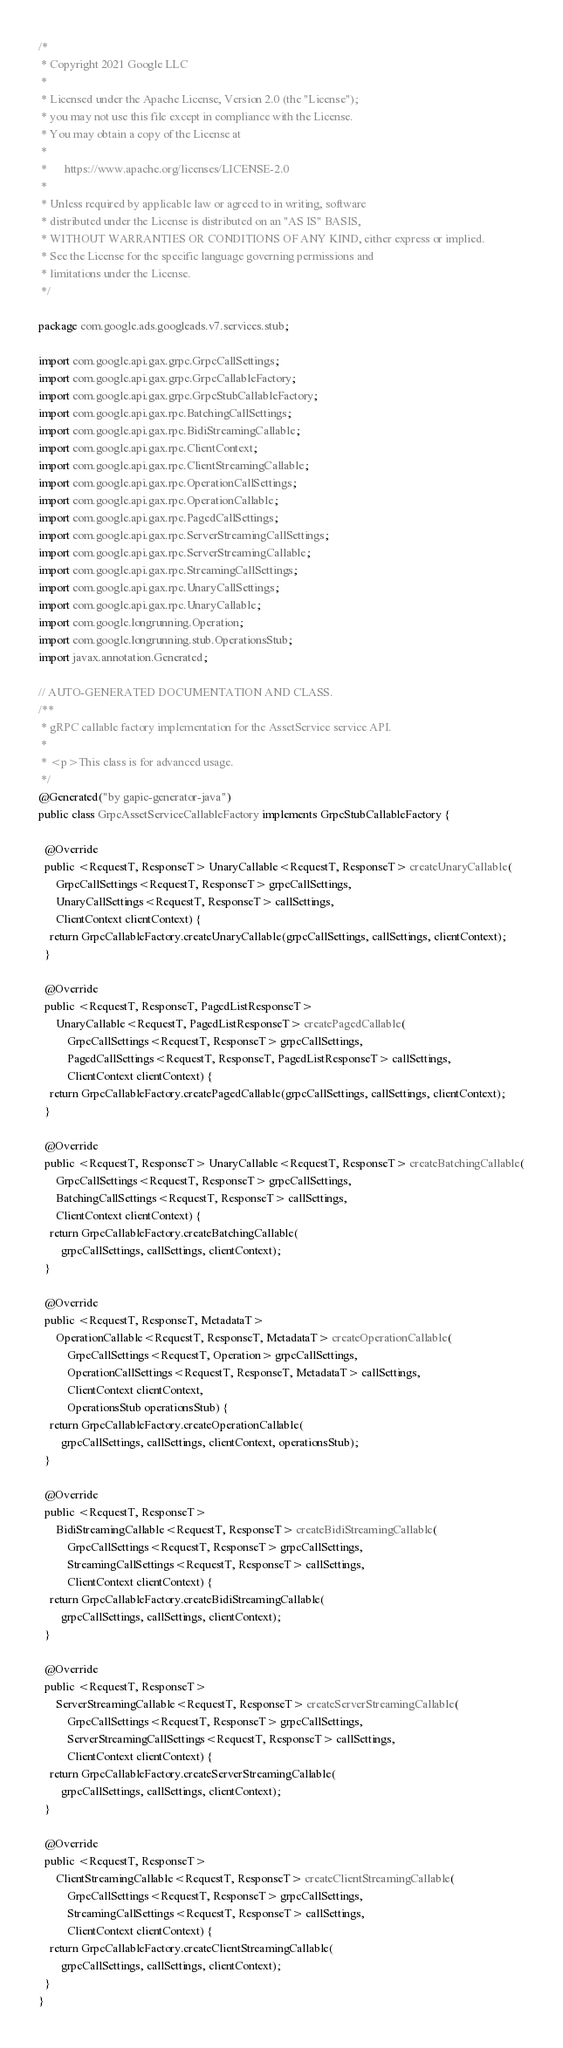Convert code to text. <code><loc_0><loc_0><loc_500><loc_500><_Java_>/*
 * Copyright 2021 Google LLC
 *
 * Licensed under the Apache License, Version 2.0 (the "License");
 * you may not use this file except in compliance with the License.
 * You may obtain a copy of the License at
 *
 *      https://www.apache.org/licenses/LICENSE-2.0
 *
 * Unless required by applicable law or agreed to in writing, software
 * distributed under the License is distributed on an "AS IS" BASIS,
 * WITHOUT WARRANTIES OR CONDITIONS OF ANY KIND, either express or implied.
 * See the License for the specific language governing permissions and
 * limitations under the License.
 */

package com.google.ads.googleads.v7.services.stub;

import com.google.api.gax.grpc.GrpcCallSettings;
import com.google.api.gax.grpc.GrpcCallableFactory;
import com.google.api.gax.grpc.GrpcStubCallableFactory;
import com.google.api.gax.rpc.BatchingCallSettings;
import com.google.api.gax.rpc.BidiStreamingCallable;
import com.google.api.gax.rpc.ClientContext;
import com.google.api.gax.rpc.ClientStreamingCallable;
import com.google.api.gax.rpc.OperationCallSettings;
import com.google.api.gax.rpc.OperationCallable;
import com.google.api.gax.rpc.PagedCallSettings;
import com.google.api.gax.rpc.ServerStreamingCallSettings;
import com.google.api.gax.rpc.ServerStreamingCallable;
import com.google.api.gax.rpc.StreamingCallSettings;
import com.google.api.gax.rpc.UnaryCallSettings;
import com.google.api.gax.rpc.UnaryCallable;
import com.google.longrunning.Operation;
import com.google.longrunning.stub.OperationsStub;
import javax.annotation.Generated;

// AUTO-GENERATED DOCUMENTATION AND CLASS.
/**
 * gRPC callable factory implementation for the AssetService service API.
 *
 * <p>This class is for advanced usage.
 */
@Generated("by gapic-generator-java")
public class GrpcAssetServiceCallableFactory implements GrpcStubCallableFactory {

  @Override
  public <RequestT, ResponseT> UnaryCallable<RequestT, ResponseT> createUnaryCallable(
      GrpcCallSettings<RequestT, ResponseT> grpcCallSettings,
      UnaryCallSettings<RequestT, ResponseT> callSettings,
      ClientContext clientContext) {
    return GrpcCallableFactory.createUnaryCallable(grpcCallSettings, callSettings, clientContext);
  }

  @Override
  public <RequestT, ResponseT, PagedListResponseT>
      UnaryCallable<RequestT, PagedListResponseT> createPagedCallable(
          GrpcCallSettings<RequestT, ResponseT> grpcCallSettings,
          PagedCallSettings<RequestT, ResponseT, PagedListResponseT> callSettings,
          ClientContext clientContext) {
    return GrpcCallableFactory.createPagedCallable(grpcCallSettings, callSettings, clientContext);
  }

  @Override
  public <RequestT, ResponseT> UnaryCallable<RequestT, ResponseT> createBatchingCallable(
      GrpcCallSettings<RequestT, ResponseT> grpcCallSettings,
      BatchingCallSettings<RequestT, ResponseT> callSettings,
      ClientContext clientContext) {
    return GrpcCallableFactory.createBatchingCallable(
        grpcCallSettings, callSettings, clientContext);
  }

  @Override
  public <RequestT, ResponseT, MetadataT>
      OperationCallable<RequestT, ResponseT, MetadataT> createOperationCallable(
          GrpcCallSettings<RequestT, Operation> grpcCallSettings,
          OperationCallSettings<RequestT, ResponseT, MetadataT> callSettings,
          ClientContext clientContext,
          OperationsStub operationsStub) {
    return GrpcCallableFactory.createOperationCallable(
        grpcCallSettings, callSettings, clientContext, operationsStub);
  }

  @Override
  public <RequestT, ResponseT>
      BidiStreamingCallable<RequestT, ResponseT> createBidiStreamingCallable(
          GrpcCallSettings<RequestT, ResponseT> grpcCallSettings,
          StreamingCallSettings<RequestT, ResponseT> callSettings,
          ClientContext clientContext) {
    return GrpcCallableFactory.createBidiStreamingCallable(
        grpcCallSettings, callSettings, clientContext);
  }

  @Override
  public <RequestT, ResponseT>
      ServerStreamingCallable<RequestT, ResponseT> createServerStreamingCallable(
          GrpcCallSettings<RequestT, ResponseT> grpcCallSettings,
          ServerStreamingCallSettings<RequestT, ResponseT> callSettings,
          ClientContext clientContext) {
    return GrpcCallableFactory.createServerStreamingCallable(
        grpcCallSettings, callSettings, clientContext);
  }

  @Override
  public <RequestT, ResponseT>
      ClientStreamingCallable<RequestT, ResponseT> createClientStreamingCallable(
          GrpcCallSettings<RequestT, ResponseT> grpcCallSettings,
          StreamingCallSettings<RequestT, ResponseT> callSettings,
          ClientContext clientContext) {
    return GrpcCallableFactory.createClientStreamingCallable(
        grpcCallSettings, callSettings, clientContext);
  }
}
</code> 